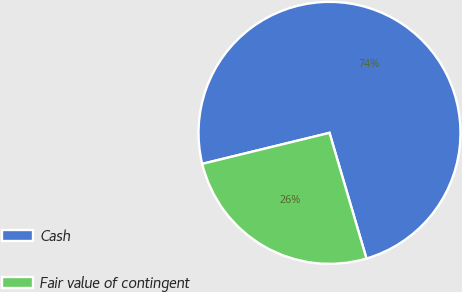<chart> <loc_0><loc_0><loc_500><loc_500><pie_chart><fcel>Cash<fcel>Fair value of contingent<nl><fcel>74.25%<fcel>25.75%<nl></chart> 